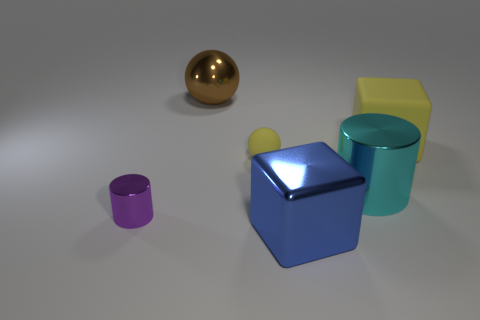Add 4 tiny red shiny blocks. How many objects exist? 10 Subtract 1 spheres. How many spheres are left? 1 Subtract all purple cylinders. How many cylinders are left? 1 Add 2 large cyan metal cylinders. How many large cyan metal cylinders are left? 3 Add 5 tiny blue metallic objects. How many tiny blue metallic objects exist? 5 Subtract 0 gray cubes. How many objects are left? 6 Subtract all spheres. How many objects are left? 4 Subtract all yellow balls. Subtract all red cylinders. How many balls are left? 1 Subtract all green blocks. How many brown balls are left? 1 Subtract all cyan cylinders. Subtract all big blocks. How many objects are left? 3 